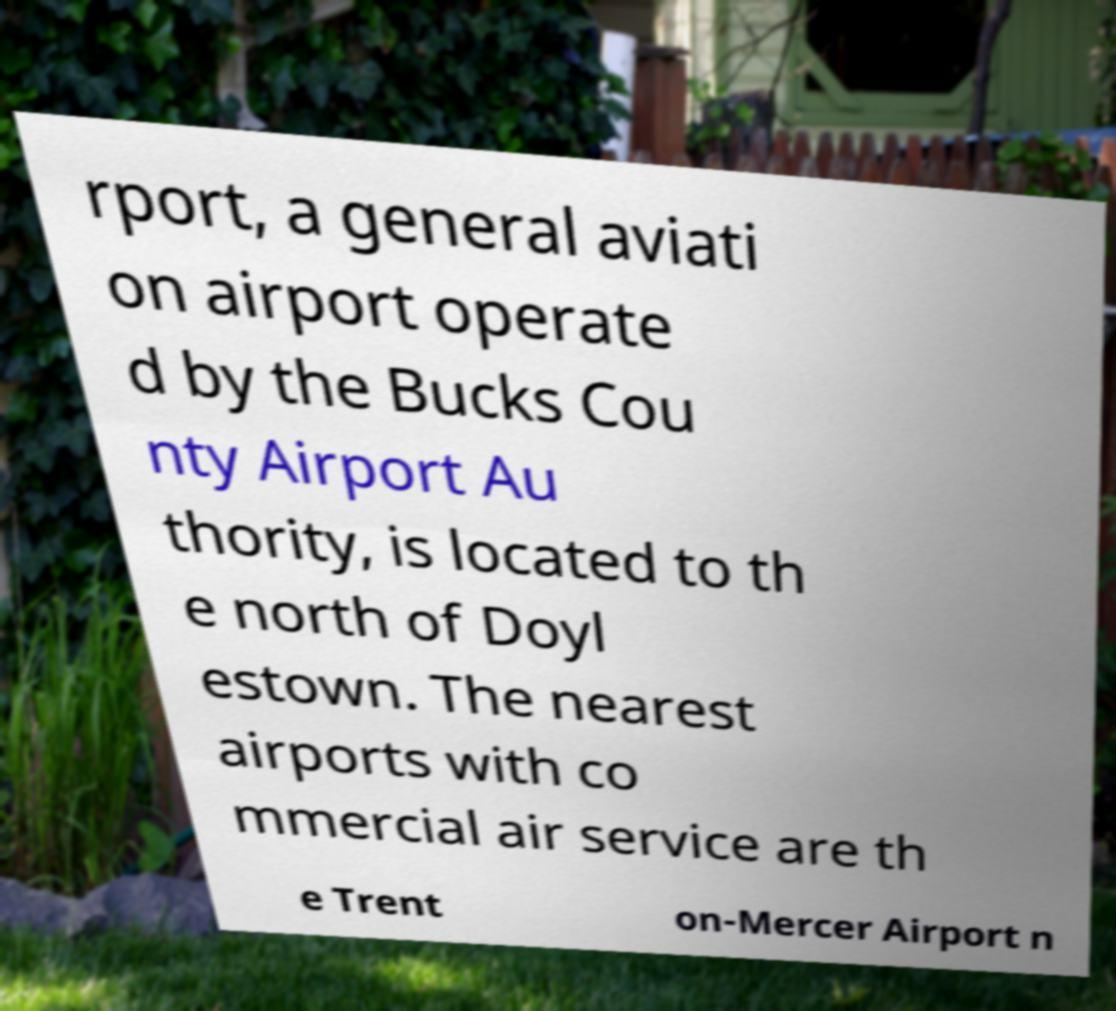Can you read and provide the text displayed in the image?This photo seems to have some interesting text. Can you extract and type it out for me? rport, a general aviati on airport operate d by the Bucks Cou nty Airport Au thority, is located to th e north of Doyl estown. The nearest airports with co mmercial air service are th e Trent on-Mercer Airport n 